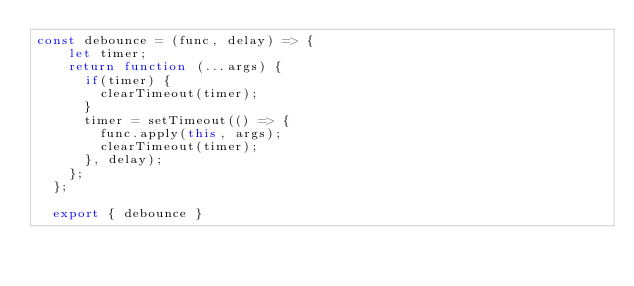Convert code to text. <code><loc_0><loc_0><loc_500><loc_500><_JavaScript_>const debounce = (func, delay) => {
    let timer;
    return function (...args) {
      if(timer) {
        clearTimeout(timer);
      }
      timer = setTimeout(() => {
        func.apply(this, args);
        clearTimeout(timer);
      }, delay);
    };
  };

  export { debounce }</code> 